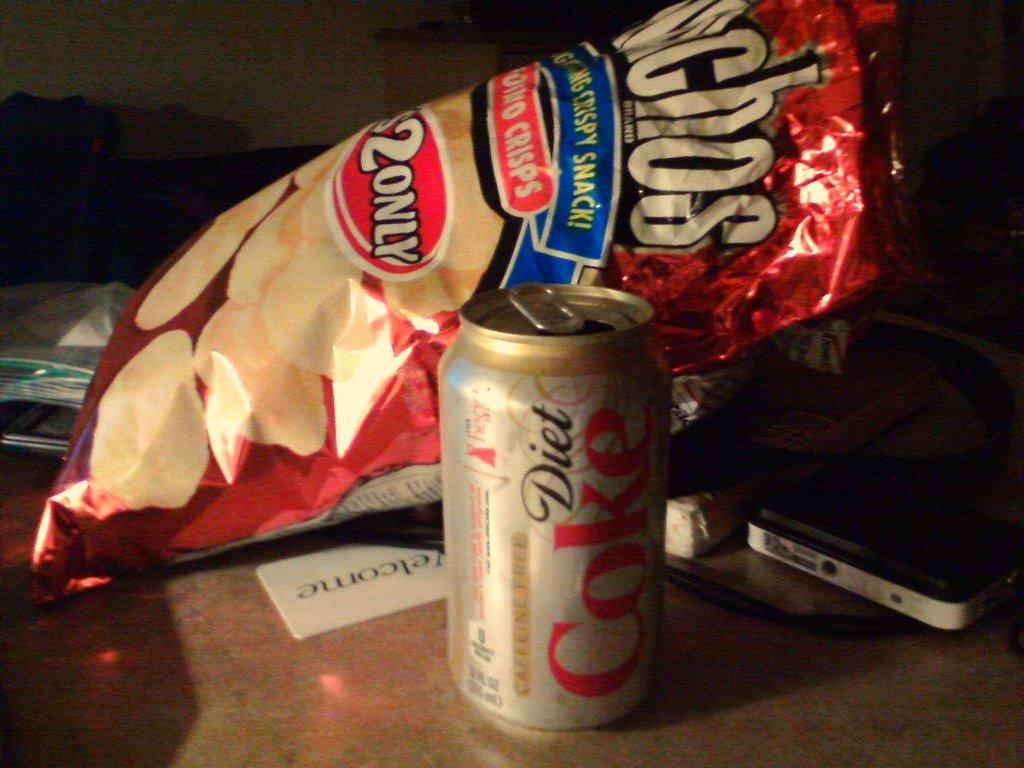<image>
Give a short and clear explanation of the subsequent image. Next to the can of diet Coke is a bag of chips. 